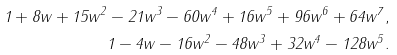Convert formula to latex. <formula><loc_0><loc_0><loc_500><loc_500>1 + 8 w + 1 5 w ^ { 2 } - 2 1 w ^ { 3 } - 6 0 w ^ { 4 } + 1 6 w ^ { 5 } + 9 6 w ^ { 6 } + 6 4 w ^ { 7 } , \\ 1 - 4 w - 1 6 w ^ { 2 } - 4 8 w ^ { 3 } + 3 2 w ^ { 4 } - 1 2 8 w ^ { 5 } .</formula> 